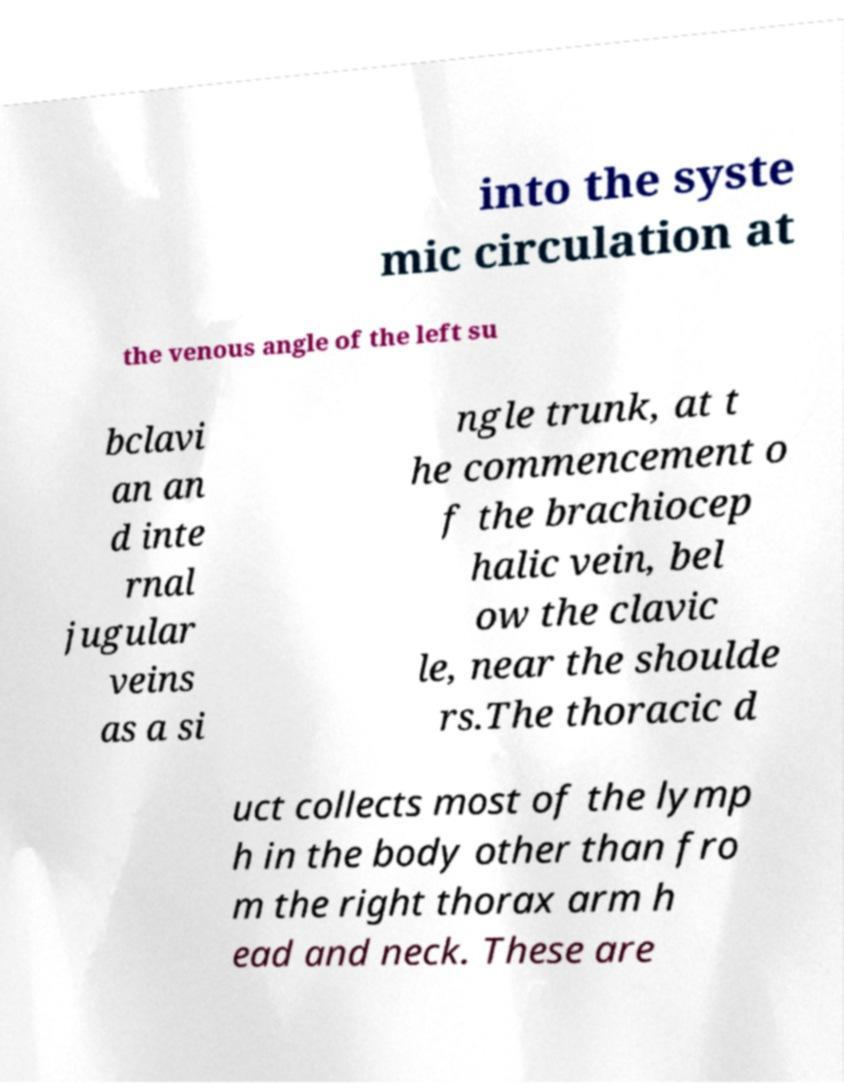For documentation purposes, I need the text within this image transcribed. Could you provide that? into the syste mic circulation at the venous angle of the left su bclavi an an d inte rnal jugular veins as a si ngle trunk, at t he commencement o f the brachiocep halic vein, bel ow the clavic le, near the shoulde rs.The thoracic d uct collects most of the lymp h in the body other than fro m the right thorax arm h ead and neck. These are 